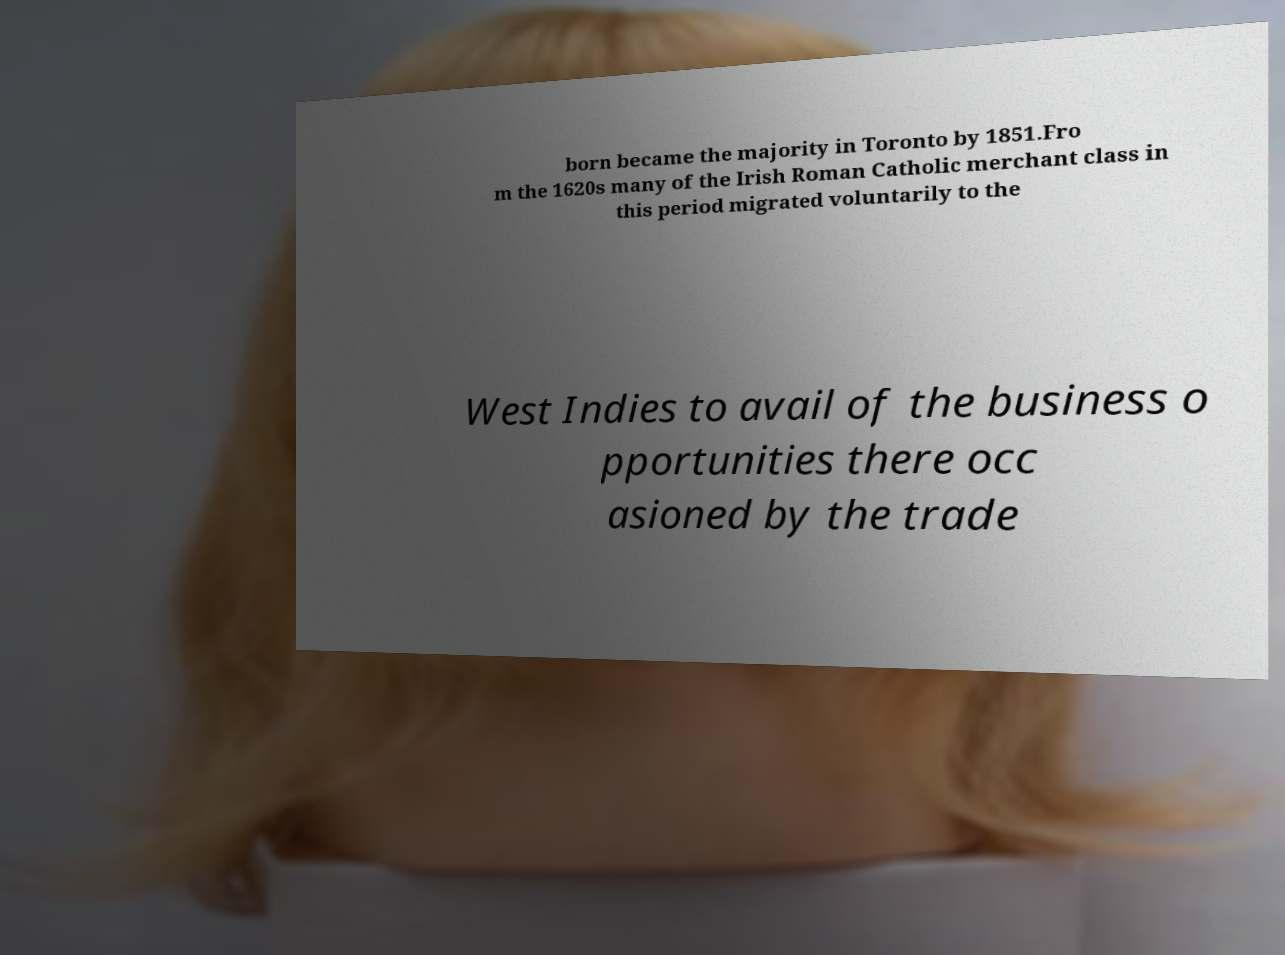What messages or text are displayed in this image? I need them in a readable, typed format. born became the majority in Toronto by 1851.Fro m the 1620s many of the Irish Roman Catholic merchant class in this period migrated voluntarily to the West Indies to avail of the business o pportunities there occ asioned by the trade 